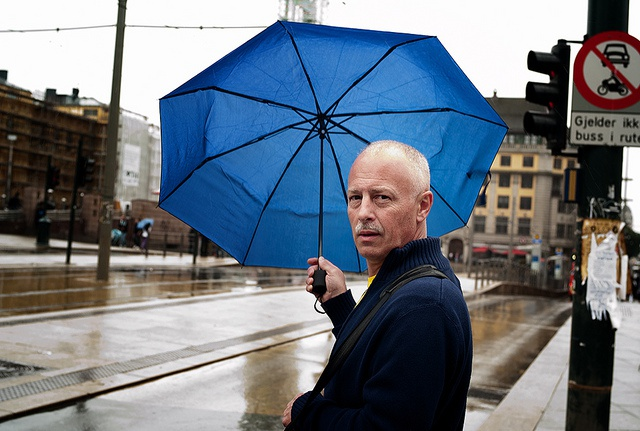Describe the objects in this image and their specific colors. I can see umbrella in white, blue, navy, and gray tones, people in white, black, brown, tan, and navy tones, traffic light in white, black, gray, and maroon tones, handbag in white, black, gray, darkblue, and navy tones, and traffic light in black and white tones in this image. 